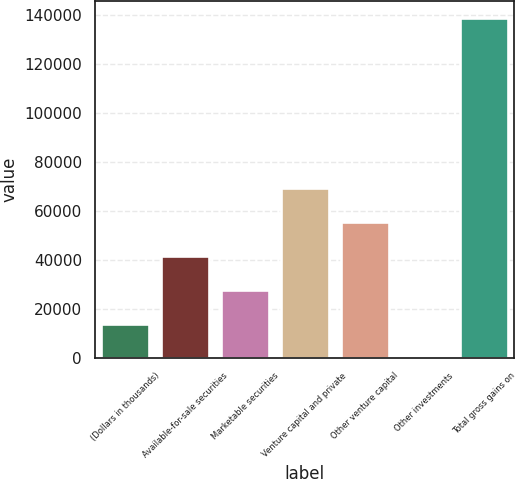<chart> <loc_0><loc_0><loc_500><loc_500><bar_chart><fcel>(Dollars in thousands)<fcel>Available-for-sale securities<fcel>Marketable securities<fcel>Venture capital and private<fcel>Other venture capital<fcel>Other investments<fcel>Total gross gains on<nl><fcel>14003<fcel>41729<fcel>27866<fcel>69455<fcel>55592<fcel>140<fcel>138770<nl></chart> 